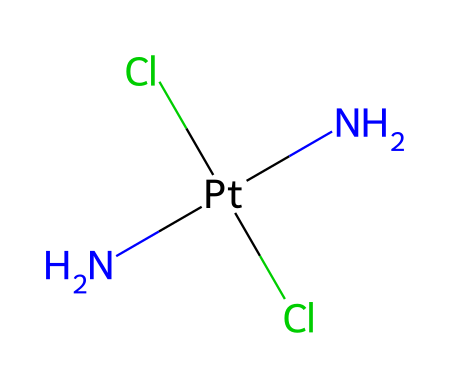What is the central metal atom in this compound? The compound contains the metal platinum as its central atom, indicated by "Pt" in the SMILES representation.
Answer: platinum How many chloride ions are present in this structure? The SMILES shows "Cl" appearing twice, which indicates that there are two chloride ions bonded to the platinum.
Answer: two What type of bonding is indicated between the platinum and the nitrogen atoms? In the structure, nitrogen atoms are directly bonded to the platinum, signifying coordination or covalent bonding typical in complexes involving metals.
Answer: covalent How many nitrogen atoms are linked to the platinum atom? The notation "N[Pt](N)(Cl)Cl" shows two "N" symbols connected to the "Pt," signifying two nitrogen atoms.
Answer: two What is the oxidation state of platinum in this compound? To determine the oxidation state, consider that each Cl has a -1 charge, and each N is neutral; thus, platinum must be in the +2 oxidation state to balance the overall charge to zero.
Answer: +2 Which chemical category does this complex belong to? This compound is a platinum-based coordination complex, specifically a metal complex used in pharmaceuticals like cancer-fighting drugs.
Answer: coordination complex What role do the chloride ions play in this chemical compound? Chloride ions may function as ligands that stabilize the metal center and affect its reactivity and interaction with biological targets in drug development.
Answer: ligands 